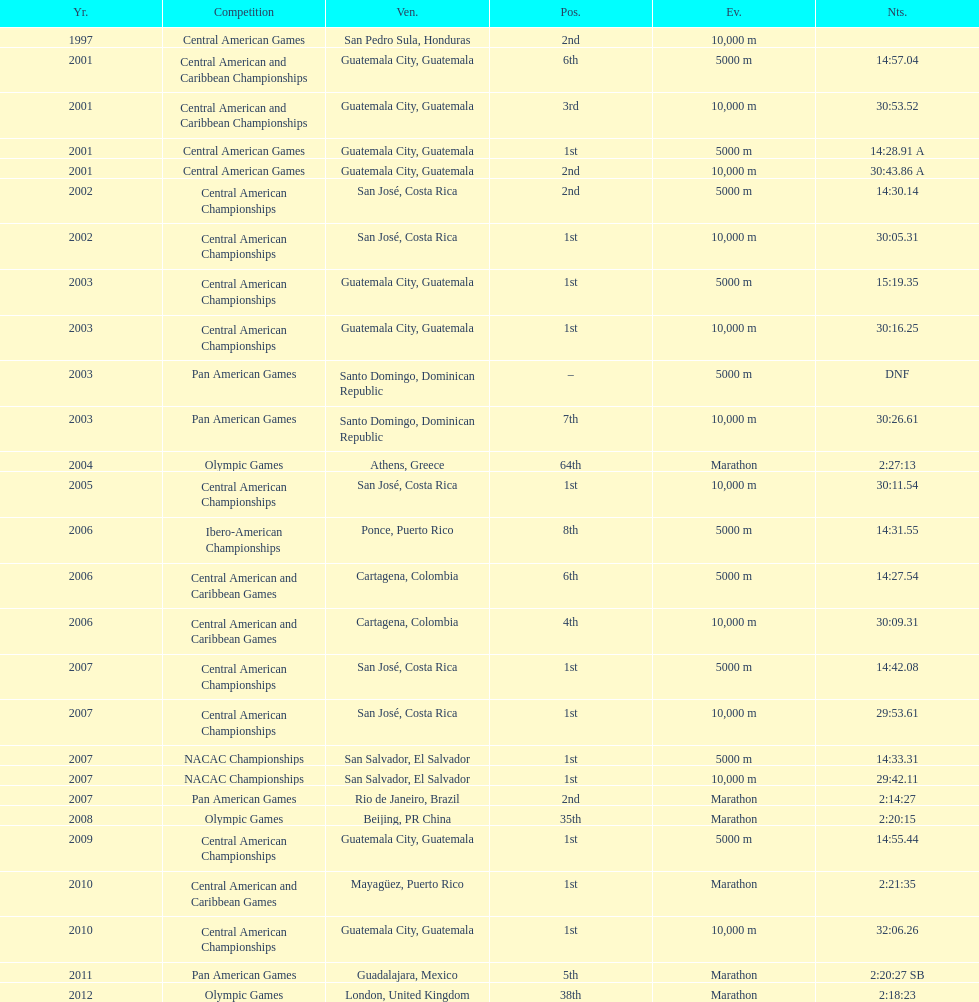Would you mind parsing the complete table? {'header': ['Yr.', 'Competition', 'Ven.', 'Pos.', 'Ev.', 'Nts.'], 'rows': [['1997', 'Central American Games', 'San Pedro Sula, Honduras', '2nd', '10,000 m', ''], ['2001', 'Central American and Caribbean Championships', 'Guatemala City, Guatemala', '6th', '5000 m', '14:57.04'], ['2001', 'Central American and Caribbean Championships', 'Guatemala City, Guatemala', '3rd', '10,000 m', '30:53.52'], ['2001', 'Central American Games', 'Guatemala City, Guatemala', '1st', '5000 m', '14:28.91 A'], ['2001', 'Central American Games', 'Guatemala City, Guatemala', '2nd', '10,000 m', '30:43.86 A'], ['2002', 'Central American Championships', 'San José, Costa Rica', '2nd', '5000 m', '14:30.14'], ['2002', 'Central American Championships', 'San José, Costa Rica', '1st', '10,000 m', '30:05.31'], ['2003', 'Central American Championships', 'Guatemala City, Guatemala', '1st', '5000 m', '15:19.35'], ['2003', 'Central American Championships', 'Guatemala City, Guatemala', '1st', '10,000 m', '30:16.25'], ['2003', 'Pan American Games', 'Santo Domingo, Dominican Republic', '–', '5000 m', 'DNF'], ['2003', 'Pan American Games', 'Santo Domingo, Dominican Republic', '7th', '10,000 m', '30:26.61'], ['2004', 'Olympic Games', 'Athens, Greece', '64th', 'Marathon', '2:27:13'], ['2005', 'Central American Championships', 'San José, Costa Rica', '1st', '10,000 m', '30:11.54'], ['2006', 'Ibero-American Championships', 'Ponce, Puerto Rico', '8th', '5000 m', '14:31.55'], ['2006', 'Central American and Caribbean Games', 'Cartagena, Colombia', '6th', '5000 m', '14:27.54'], ['2006', 'Central American and Caribbean Games', 'Cartagena, Colombia', '4th', '10,000 m', '30:09.31'], ['2007', 'Central American Championships', 'San José, Costa Rica', '1st', '5000 m', '14:42.08'], ['2007', 'Central American Championships', 'San José, Costa Rica', '1st', '10,000 m', '29:53.61'], ['2007', 'NACAC Championships', 'San Salvador, El Salvador', '1st', '5000 m', '14:33.31'], ['2007', 'NACAC Championships', 'San Salvador, El Salvador', '1st', '10,000 m', '29:42.11'], ['2007', 'Pan American Games', 'Rio de Janeiro, Brazil', '2nd', 'Marathon', '2:14:27'], ['2008', 'Olympic Games', 'Beijing, PR China', '35th', 'Marathon', '2:20:15'], ['2009', 'Central American Championships', 'Guatemala City, Guatemala', '1st', '5000 m', '14:55.44'], ['2010', 'Central American and Caribbean Games', 'Mayagüez, Puerto Rico', '1st', 'Marathon', '2:21:35'], ['2010', 'Central American Championships', 'Guatemala City, Guatemala', '1st', '10,000 m', '32:06.26'], ['2011', 'Pan American Games', 'Guadalajara, Mexico', '5th', 'Marathon', '2:20:27 SB'], ['2012', 'Olympic Games', 'London, United Kingdom', '38th', 'Marathon', '2:18:23']]} How many times has the position of 1st been achieved? 12. 